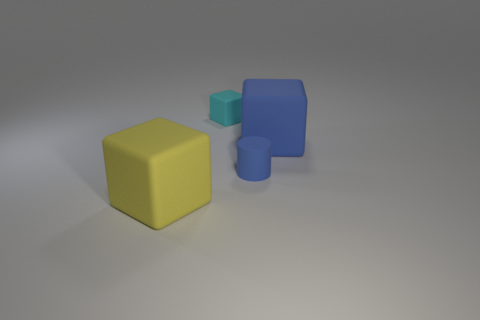Subtract all green cylinders. Subtract all gray spheres. How many cylinders are left? 1 Add 4 spheres. How many objects exist? 8 Subtract all cylinders. How many objects are left? 3 Add 4 tiny cyan rubber things. How many tiny cyan rubber things are left? 5 Add 3 small gray objects. How many small gray objects exist? 3 Subtract 0 gray cylinders. How many objects are left? 4 Subtract all yellow cubes. Subtract all large yellow cubes. How many objects are left? 2 